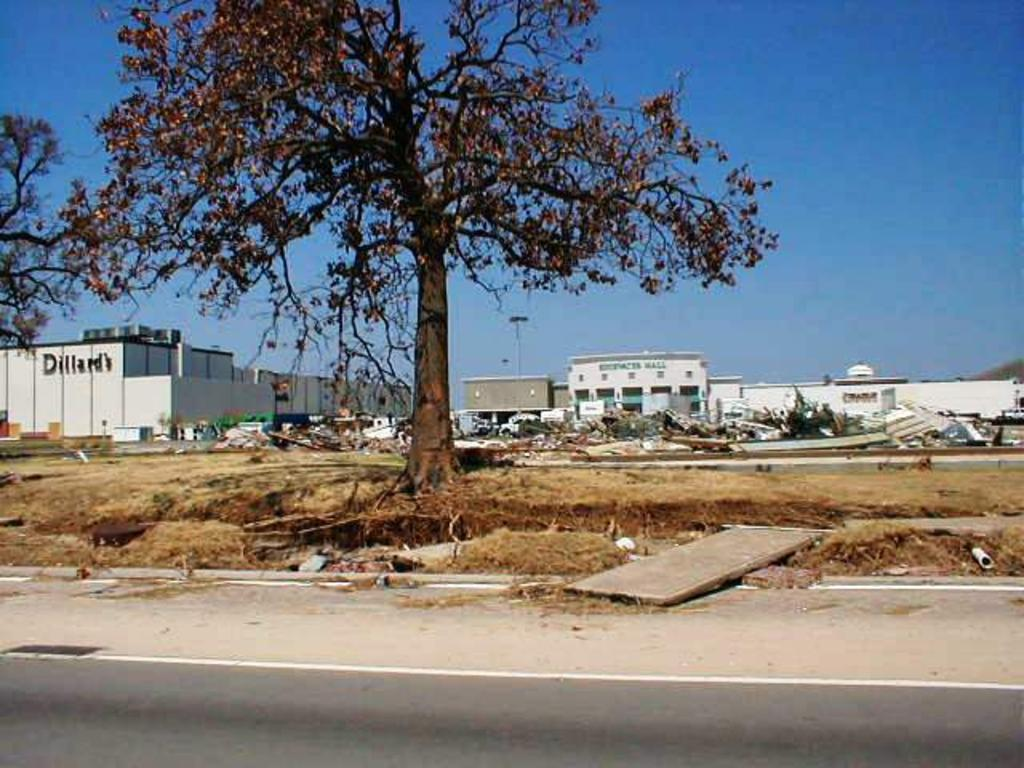What type of vegetation can be seen in the image? There are trees in the image. What type of structures are present in the image? There are buildings in the image. How many objects can be identified in the image? There are many objects in the image. What type of ground cover is visible in the image? There is grass in the image. What is the flat, rectangular object in the image? There is a board in the image. What type of pathway is present in the image? There is a road in the image. What is visible at the top of the image? The sky is visible at the top of the image. How many beds are visible in the image? There are no beds present in the image. What type of feather can be seen flying in the image? There is no feather present in the image. 